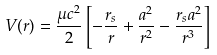Convert formula to latex. <formula><loc_0><loc_0><loc_500><loc_500>V ( r ) = { \frac { \mu c ^ { 2 } } { 2 } } \left [ - { \frac { r _ { s } } { r } } + { \frac { a ^ { 2 } } { r ^ { 2 } } } - { \frac { r _ { s } a ^ { 2 } } { r ^ { 3 } } } \right ]</formula> 